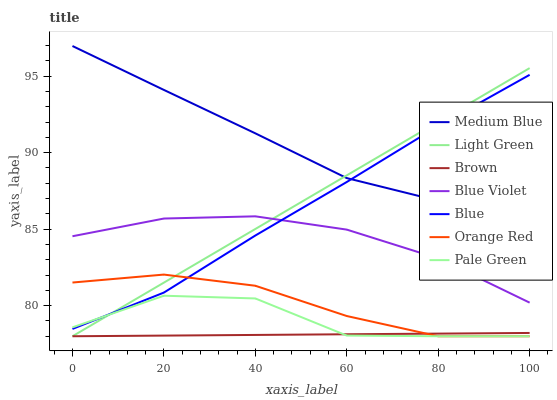Does Brown have the minimum area under the curve?
Answer yes or no. Yes. Does Medium Blue have the maximum area under the curve?
Answer yes or no. Yes. Does Medium Blue have the minimum area under the curve?
Answer yes or no. No. Does Brown have the maximum area under the curve?
Answer yes or no. No. Is Brown the smoothest?
Answer yes or no. Yes. Is Pale Green the roughest?
Answer yes or no. Yes. Is Medium Blue the smoothest?
Answer yes or no. No. Is Medium Blue the roughest?
Answer yes or no. No. Does Brown have the lowest value?
Answer yes or no. Yes. Does Medium Blue have the lowest value?
Answer yes or no. No. Does Medium Blue have the highest value?
Answer yes or no. Yes. Does Brown have the highest value?
Answer yes or no. No. Is Brown less than Medium Blue?
Answer yes or no. Yes. Is Medium Blue greater than Orange Red?
Answer yes or no. Yes. Does Blue Violet intersect Blue?
Answer yes or no. Yes. Is Blue Violet less than Blue?
Answer yes or no. No. Is Blue Violet greater than Blue?
Answer yes or no. No. Does Brown intersect Medium Blue?
Answer yes or no. No. 